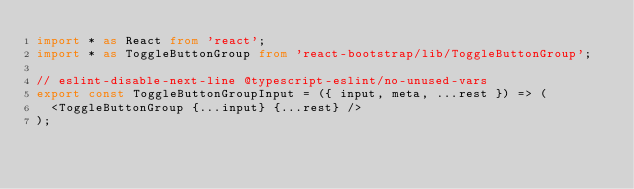Convert code to text. <code><loc_0><loc_0><loc_500><loc_500><_TypeScript_>import * as React from 'react';
import * as ToggleButtonGroup from 'react-bootstrap/lib/ToggleButtonGroup';

// eslint-disable-next-line @typescript-eslint/no-unused-vars
export const ToggleButtonGroupInput = ({ input, meta, ...rest }) => (
  <ToggleButtonGroup {...input} {...rest} />
);
</code> 